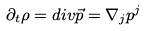Convert formula to latex. <formula><loc_0><loc_0><loc_500><loc_500>\partial _ { t } \rho = d i v { \vec { p } } = \nabla _ { j } p ^ { j }</formula> 